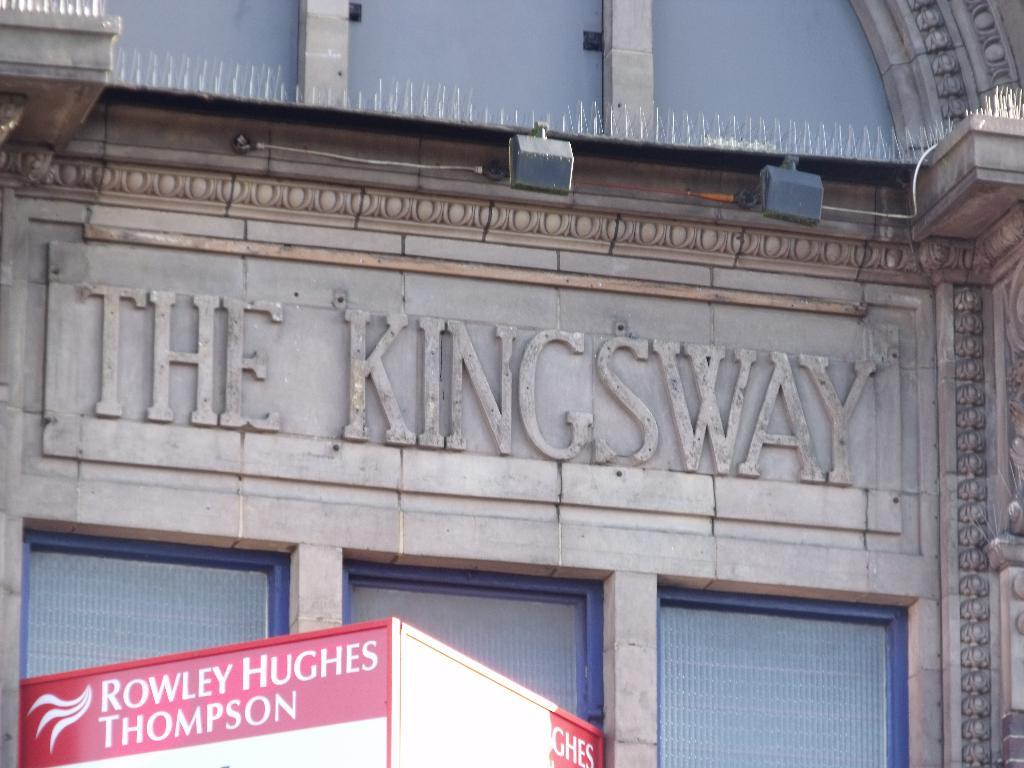What type of structure is present in the image? There is a building in the image. What is the color of the building? The building is brown in color. Is there any additional feature attached to the building? Yes, there is a red-colored board attached to the building. What can be seen in terms of illumination in the image? There are lights visible in the image. Are there any wires present in the image? Yes, there is a wire in the image. Is there any text or information displayed on the building? Yes, there is writing on the building. Can you tell me how many bears are sitting on the roof of the building in the image? There are no bears present on the roof or anywhere else in the image. 